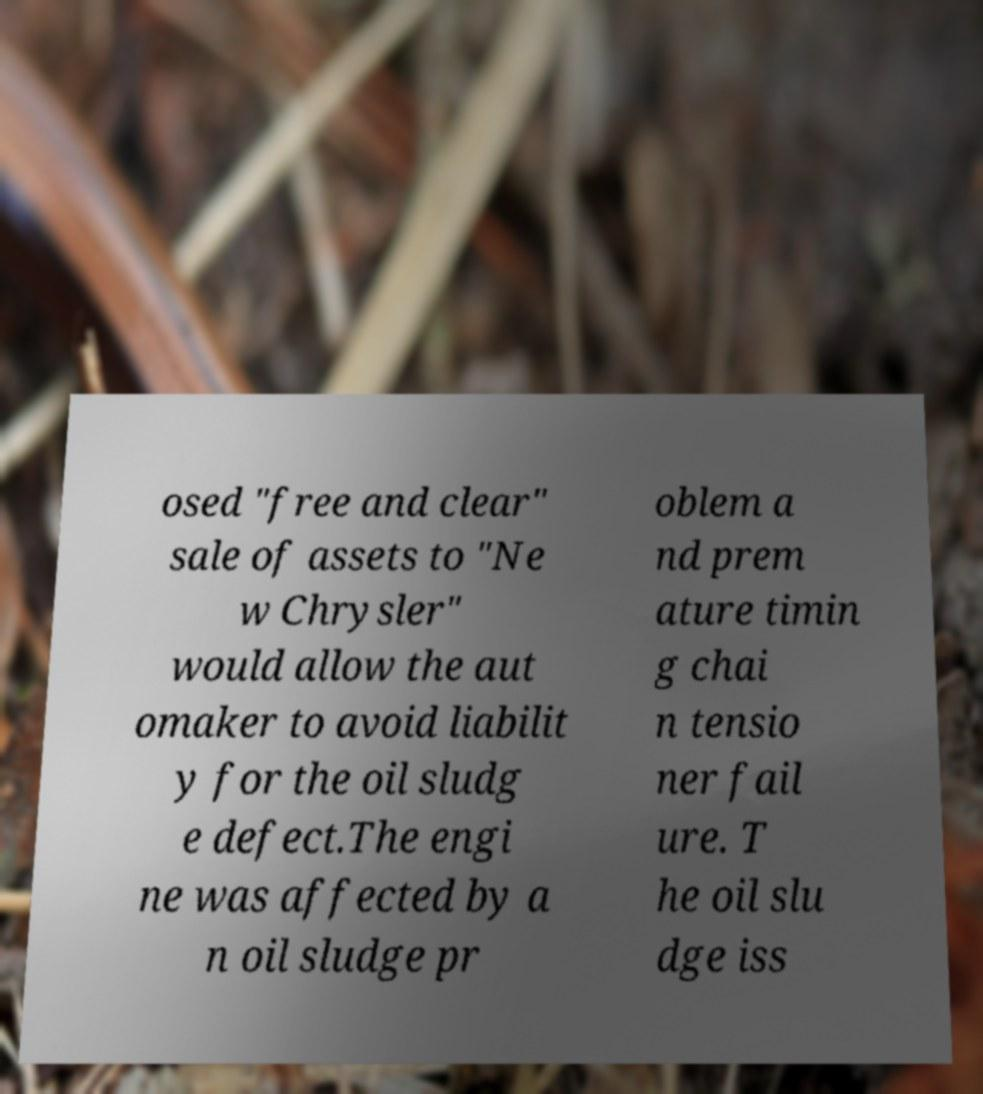Could you extract and type out the text from this image? osed "free and clear" sale of assets to "Ne w Chrysler" would allow the aut omaker to avoid liabilit y for the oil sludg e defect.The engi ne was affected by a n oil sludge pr oblem a nd prem ature timin g chai n tensio ner fail ure. T he oil slu dge iss 